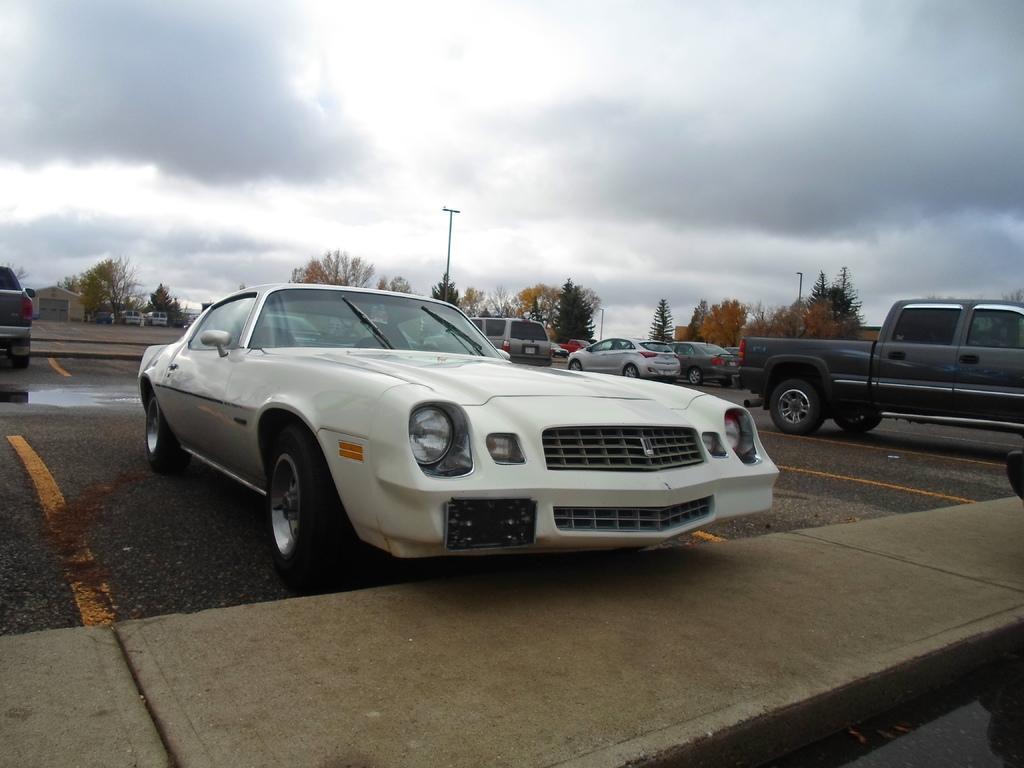Can you describe this image briefly? In this image in the center there are some cars and at the bottom there is a road and a footpath, in the background there are some trees, houses, vehicles and poles. On the top of the image there is sky. 